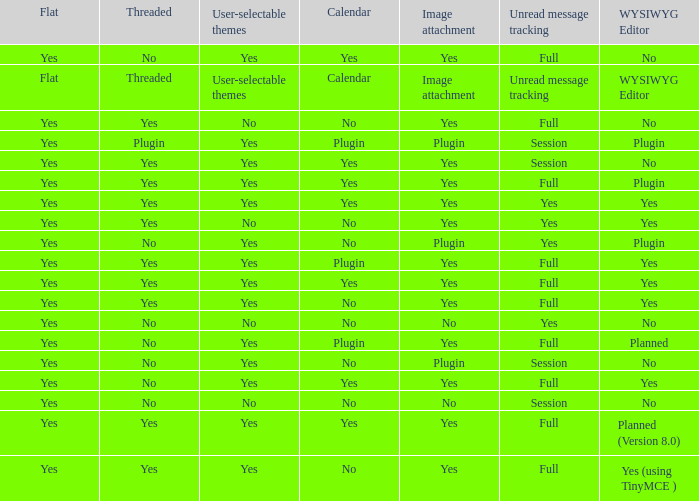Which wysiwyg editor offers user-selectable themes, session-based unread message tracking, and image attachments via plugin? No, Plugin. 